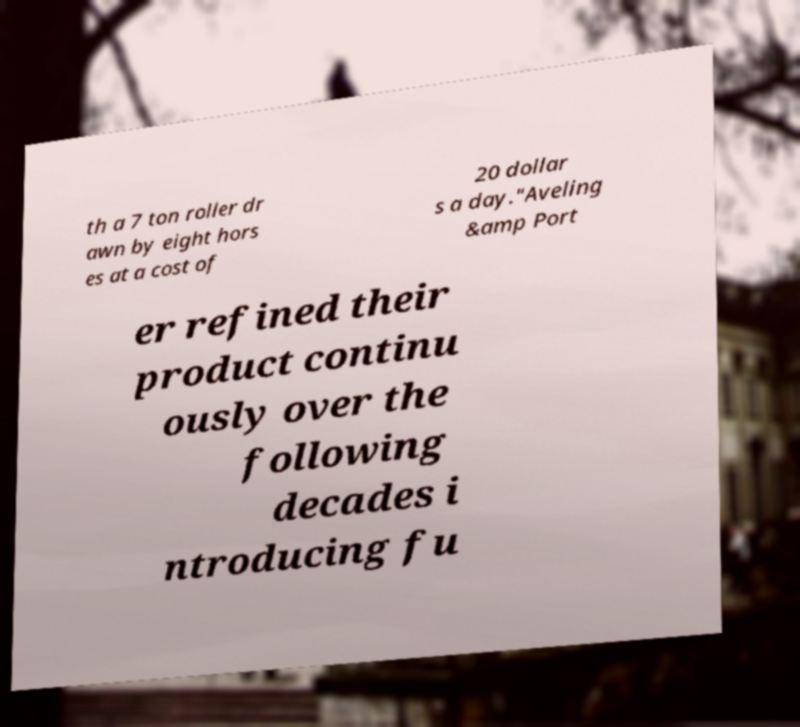I need the written content from this picture converted into text. Can you do that? th a 7 ton roller dr awn by eight hors es at a cost of 20 dollar s a day."Aveling &amp Port er refined their product continu ously over the following decades i ntroducing fu 